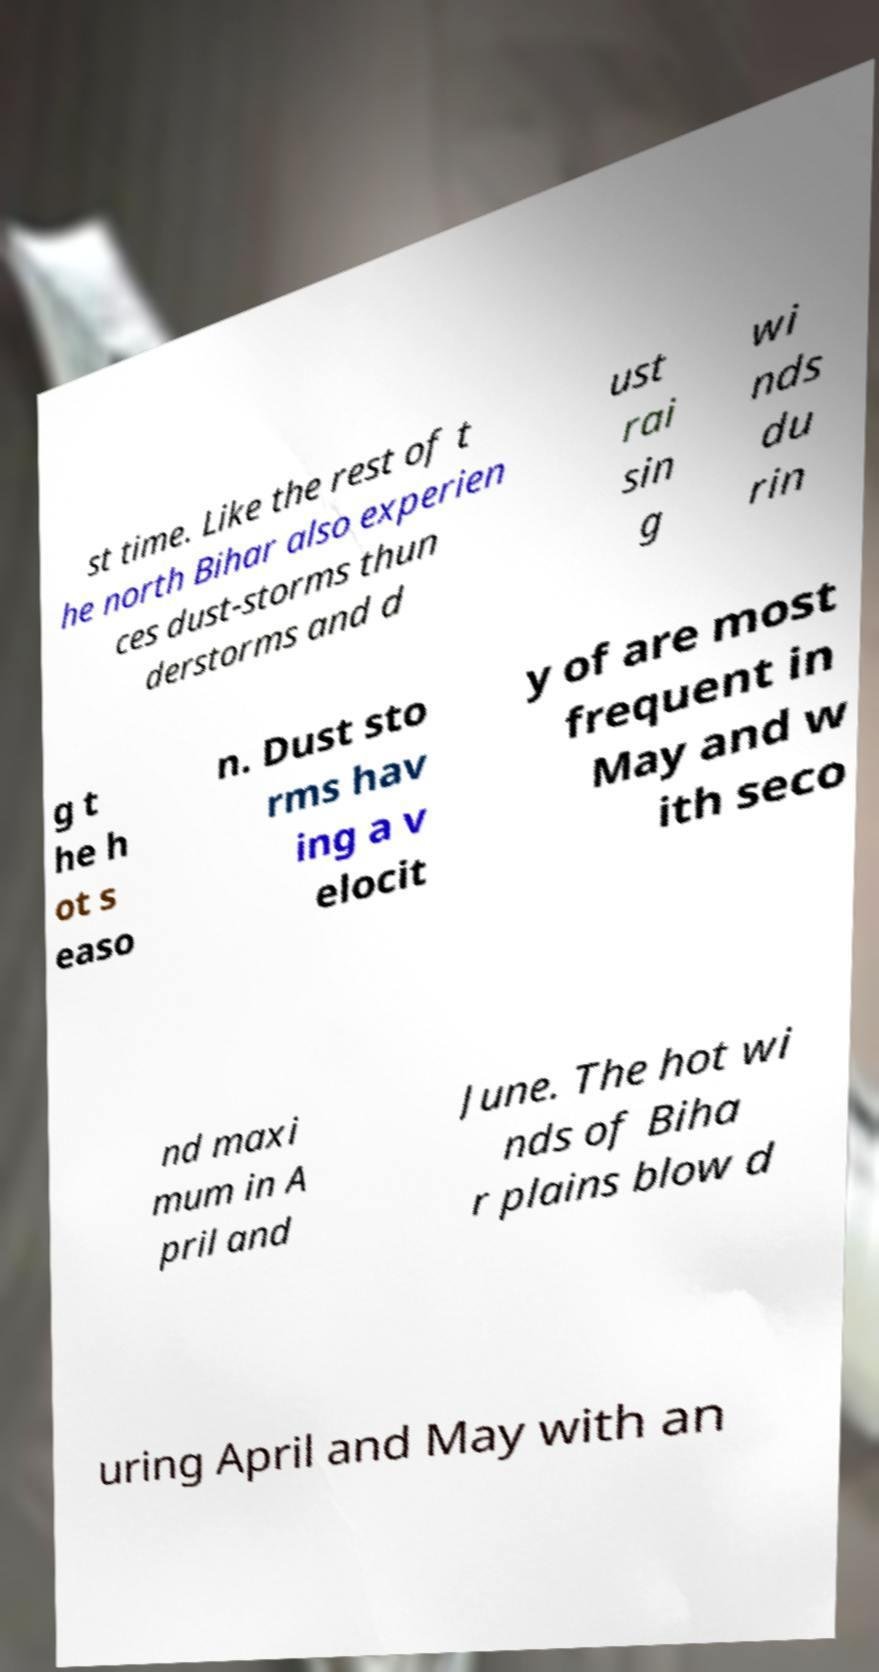Can you read and provide the text displayed in the image?This photo seems to have some interesting text. Can you extract and type it out for me? st time. Like the rest of t he north Bihar also experien ces dust-storms thun derstorms and d ust rai sin g wi nds du rin g t he h ot s easo n. Dust sto rms hav ing a v elocit y of are most frequent in May and w ith seco nd maxi mum in A pril and June. The hot wi nds of Biha r plains blow d uring April and May with an 